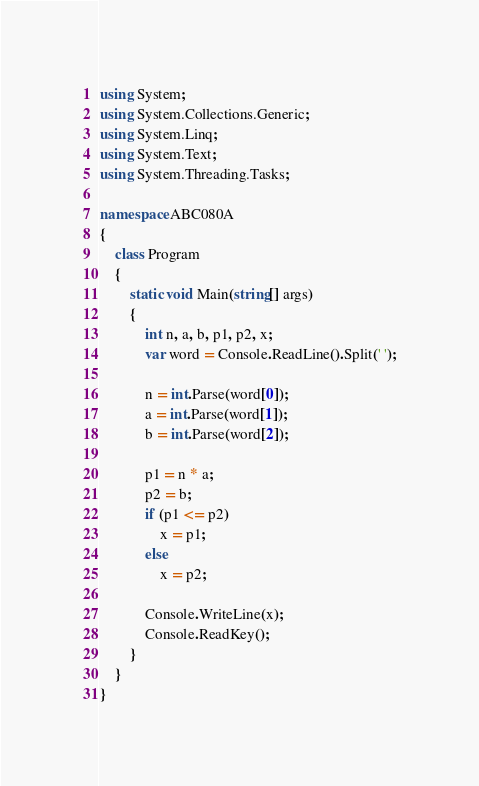<code> <loc_0><loc_0><loc_500><loc_500><_C#_>using System;
using System.Collections.Generic;
using System.Linq;
using System.Text;
using System.Threading.Tasks;

namespace ABC080A
{
    class Program
    {
        static void Main(string[] args)
        {
            int n, a, b, p1, p2, x;
            var word = Console.ReadLine().Split(' ');

            n = int.Parse(word[0]);
            a = int.Parse(word[1]);
            b = int.Parse(word[2]);

            p1 = n * a;
            p2 = b;
            if (p1 <= p2)
                x = p1;
            else 
                x = p2;

            Console.WriteLine(x);
            Console.ReadKey();
        }
    }
}
</code> 